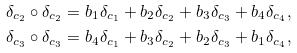Convert formula to latex. <formula><loc_0><loc_0><loc_500><loc_500>\delta _ { c _ { 2 } } \circ \delta _ { c _ { 2 } } & = b _ { 1 } \delta _ { c _ { 1 } } + b _ { 2 } \delta _ { c _ { 2 } } + b _ { 3 } \delta _ { c _ { 3 } } + b _ { 4 } \delta _ { c _ { 4 } } , \\ \delta _ { c _ { 3 } } \circ \delta _ { c _ { 3 } } & = b _ { 4 } \delta _ { c _ { 1 } } + b _ { 3 } \delta _ { c _ { 2 } } + b _ { 2 } \delta _ { c _ { 3 } } + b _ { 1 } \delta _ { c _ { 4 } } ,</formula> 